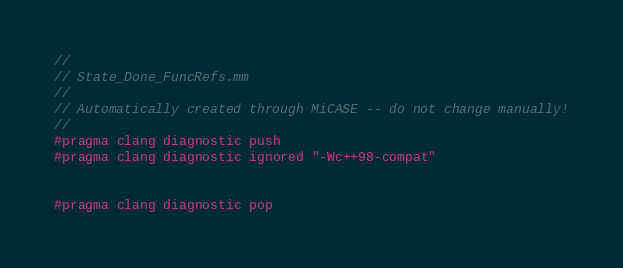<code> <loc_0><loc_0><loc_500><loc_500><_ObjectiveC_>//
// State_Done_FuncRefs.mm
//
// Automatically created through MiCASE -- do not change manually!
//
#pragma clang diagnostic push
#pragma clang diagnostic ignored "-Wc++98-compat"


#pragma clang diagnostic pop
</code> 